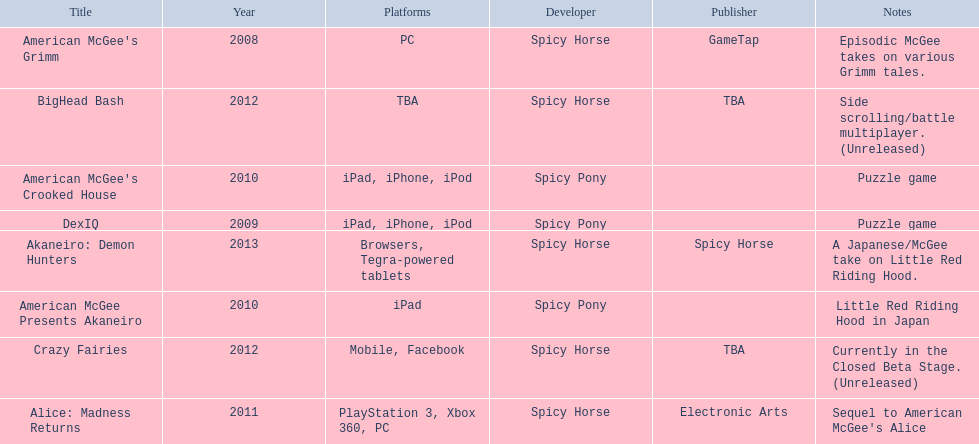Which spicy horse titles are shown? American McGee's Grimm, DexIQ, American McGee Presents Akaneiro, American McGee's Crooked House, Alice: Madness Returns, BigHead Bash, Crazy Fairies, Akaneiro: Demon Hunters. Of those, which are for the ipad? DexIQ, American McGee Presents Akaneiro, American McGee's Crooked House. Which of those are not for the iphone or ipod? American McGee Presents Akaneiro. 